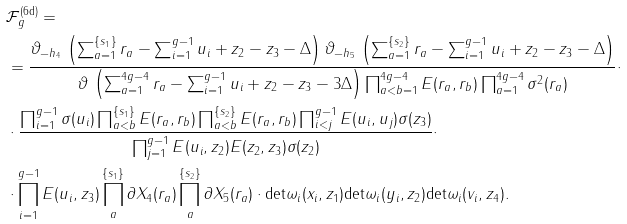<formula> <loc_0><loc_0><loc_500><loc_500>& \mathcal { F } _ { g } ^ { ( \text {6d} ) } = \\ & = \frac { \vartheta _ { - h _ { 4 } } \, \left ( \sum _ { a = 1 } ^ { \{ s _ { 1 } \} } r _ { a } - \sum _ { i = 1 } ^ { g - 1 } u _ { i } + z _ { 2 } - z _ { 3 } - \Delta \right ) \vartheta _ { - h _ { 5 } } \, \left ( \sum _ { a = 1 } ^ { \{ s _ { 2 } \} } r _ { a } - \sum _ { i = 1 } ^ { g - 1 } u _ { i } + z _ { 2 } - z _ { 3 } - \Delta \right ) } { \vartheta \, \left ( \sum _ { a = 1 } ^ { 4 g - 4 } r _ { a } - \sum _ { i = 1 } ^ { g - 1 } u _ { i } + z _ { 2 } - z _ { 3 } - 3 \Delta \right ) \prod _ { a < b = 1 } ^ { 4 g - 4 } E ( r _ { a } , r _ { b } ) \prod _ { a = 1 } ^ { 4 g - 4 } \sigma ^ { 2 } ( r _ { a } ) } \cdot \\ & \cdot \frac { \prod _ { i = 1 } ^ { g - 1 } \sigma ( u _ { i } ) \prod _ { a < b } ^ { \{ s _ { 1 } \} } E ( r _ { a } , r _ { b } ) \prod _ { a < b } ^ { \{ s _ { 2 } \} } E ( r _ { a } , r _ { b } ) \prod _ { i < j } ^ { g - 1 } E ( u _ { i } , u _ { j } ) \sigma ( z _ { 3 } ) } { \prod _ { j = 1 } ^ { g - 1 } E ( u _ { i } , z _ { 2 } ) E ( z _ { 2 } , z _ { 3 } ) \sigma ( z _ { 2 } ) } \cdot \\ & \cdot \prod _ { i = 1 } ^ { g - 1 } E ( u _ { i } , z _ { 3 } ) \prod _ { a } ^ { \{ s _ { 1 } \} } \partial X _ { 4 } ( r _ { a } ) \prod _ { a } ^ { \{ s _ { 2 } \} } \partial X _ { 5 } ( r _ { a } ) \cdot \text {det} \omega _ { i } ( x _ { i } , z _ { 1 } ) \text {det} \omega _ { i } ( y _ { i } , z _ { 2 } ) \text {det} \omega _ { i } ( v _ { i } , z _ { 4 } ) .</formula> 